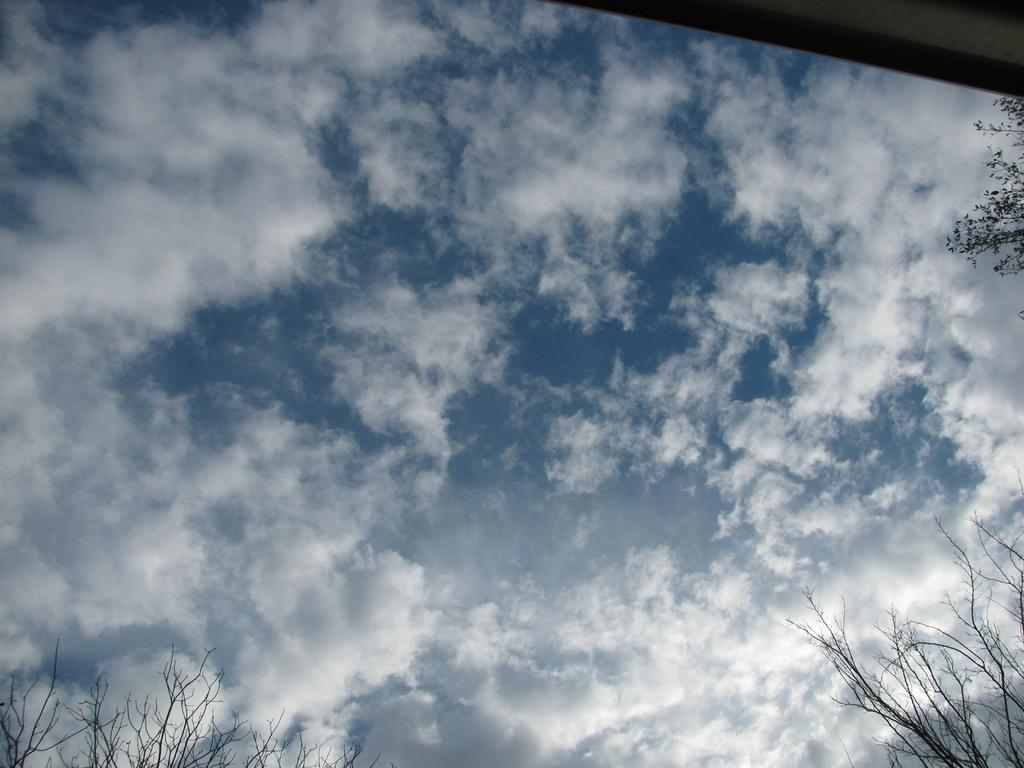What can be seen in the sky in the image? There are clouds in the sky in the image. What type of vegetation is visible in the image? There are trees visible in the image. What structure is present at the top of the image? There is a wall at the top of the image. Is there a trail leading through the wilderness in the image? There is no trail or wilderness present in the image; it features clouds, trees, and a wall. What type of material is the wall made of in the image? The provided facts do not specify the material of the wall, so it cannot be determined from the image. 